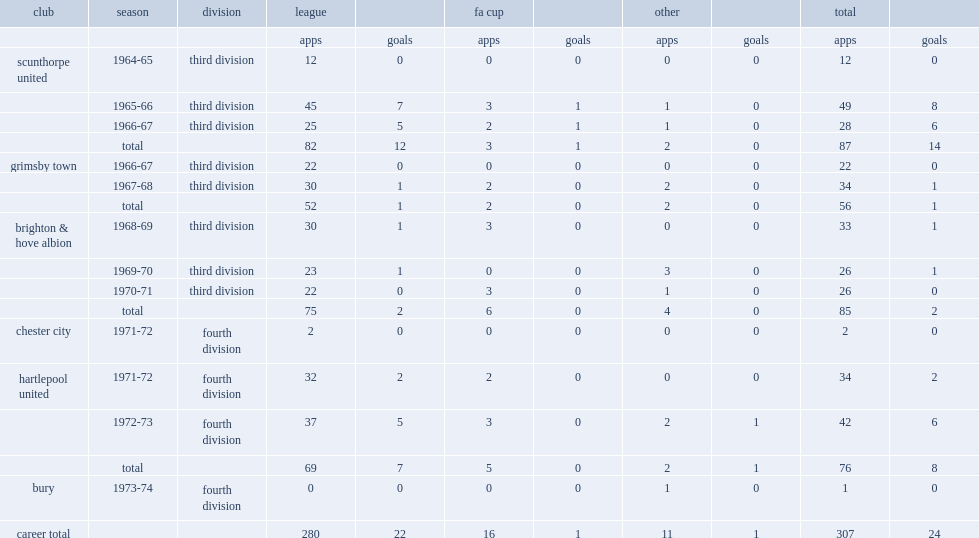In the 1973-74 season, which club did bobby smith sign in the fourth division? Bury. Parse the table in full. {'header': ['club', 'season', 'division', 'league', '', 'fa cup', '', 'other', '', 'total', ''], 'rows': [['', '', '', 'apps', 'goals', 'apps', 'goals', 'apps', 'goals', 'apps', 'goals'], ['scunthorpe united', '1964-65', 'third division', '12', '0', '0', '0', '0', '0', '12', '0'], ['', '1965-66', 'third division', '45', '7', '3', '1', '1', '0', '49', '8'], ['', '1966-67', 'third division', '25', '5', '2', '1', '1', '0', '28', '6'], ['', 'total', '', '82', '12', '3', '1', '2', '0', '87', '14'], ['grimsby town', '1966-67', 'third division', '22', '0', '0', '0', '0', '0', '22', '0'], ['', '1967-68', 'third division', '30', '1', '2', '0', '2', '0', '34', '1'], ['', 'total', '', '52', '1', '2', '0', '2', '0', '56', '1'], ['brighton & hove albion', '1968-69', 'third division', '30', '1', '3', '0', '0', '0', '33', '1'], ['', '1969-70', 'third division', '23', '1', '0', '0', '3', '0', '26', '1'], ['', '1970-71', 'third division', '22', '0', '3', '0', '1', '0', '26', '0'], ['', 'total', '', '75', '2', '6', '0', '4', '0', '85', '2'], ['chester city', '1971-72', 'fourth division', '2', '0', '0', '0', '0', '0', '2', '0'], ['hartlepool united', '1971-72', 'fourth division', '32', '2', '2', '0', '0', '0', '34', '2'], ['', '1972-73', 'fourth division', '37', '5', '3', '0', '2', '1', '42', '6'], ['', 'total', '', '69', '7', '5', '0', '2', '1', '76', '8'], ['bury', '1973-74', 'fourth division', '0', '0', '0', '0', '1', '0', '1', '0'], ['career total', '', '', '280', '22', '16', '1', '11', '1', '307', '24']]} 